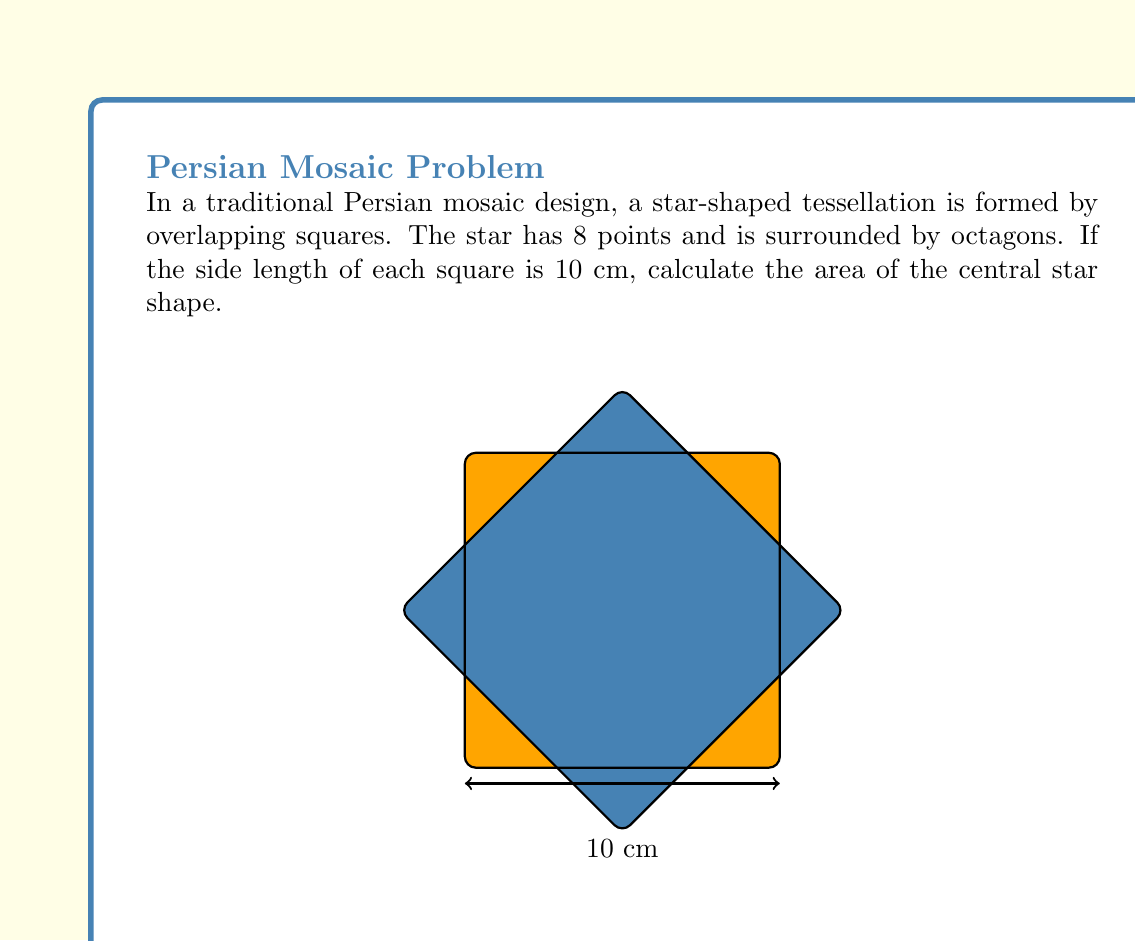Help me with this question. Let's approach this step-by-step:

1) The star is formed by the intersection of two squares rotated 45° relative to each other.

2) To find the area of the star, we need to calculate the area of one square and subtract the areas that don't belong to the star.

3) Area of one square: 
   $$A_{square} = 10^2 = 100 \text{ cm}^2$$

4) The areas we need to subtract are four right triangles, one in each corner of the square.

5) To find the area of these triangles, we need their base and height. Due to the 45° rotation, these are equal and can be calculated using the Pythagorean theorem:
   $$5^2 + 5^2 = x^2$$
   $$50 = x^2$$
   $$x = 5\sqrt{2} \text{ cm}$$

6) Area of one triangle:
   $$A_{triangle} = \frac{1}{2} \cdot 5\sqrt{2} \cdot 5\sqrt{2} = 25 \text{ cm}^2$$

7) Total area to subtract:
   $$A_{subtract} = 4 \cdot 25 = 100 \text{ cm}^2$$

8) Area of the star:
   $$A_{star} = A_{square} - A_{subtract} = 100 - 100 = 0 \text{ cm}^2$$

9) However, this is just half of the star. The complete star is formed by two such intersections, so we need to double this result:
   $$A_{total star} = 2 \cdot 0 = 0 \text{ cm}^2$$

This might seem counterintuitive, but it's correct. The star shape has no area because it's formed by the perfect overlap of the squares' edges.
Answer: $0 \text{ cm}^2$ 